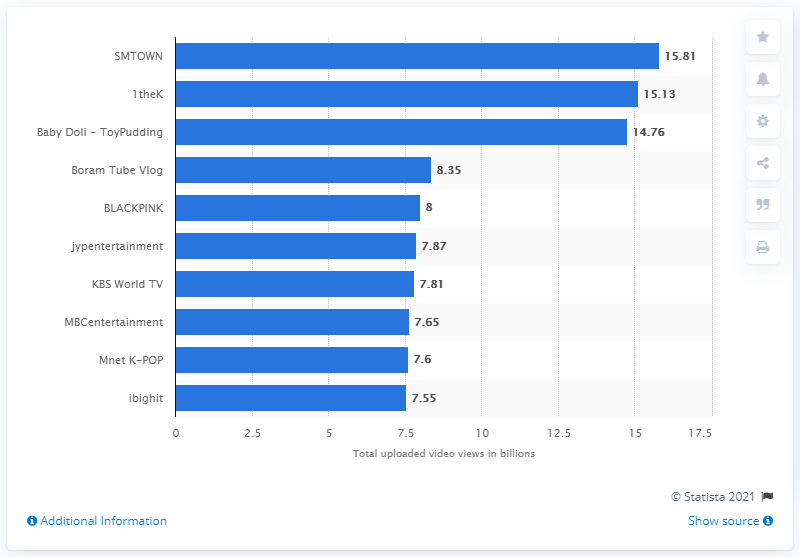Highlight a few significant elements in this photo. As of September 2020, SMTOWN had 15.81 views. 